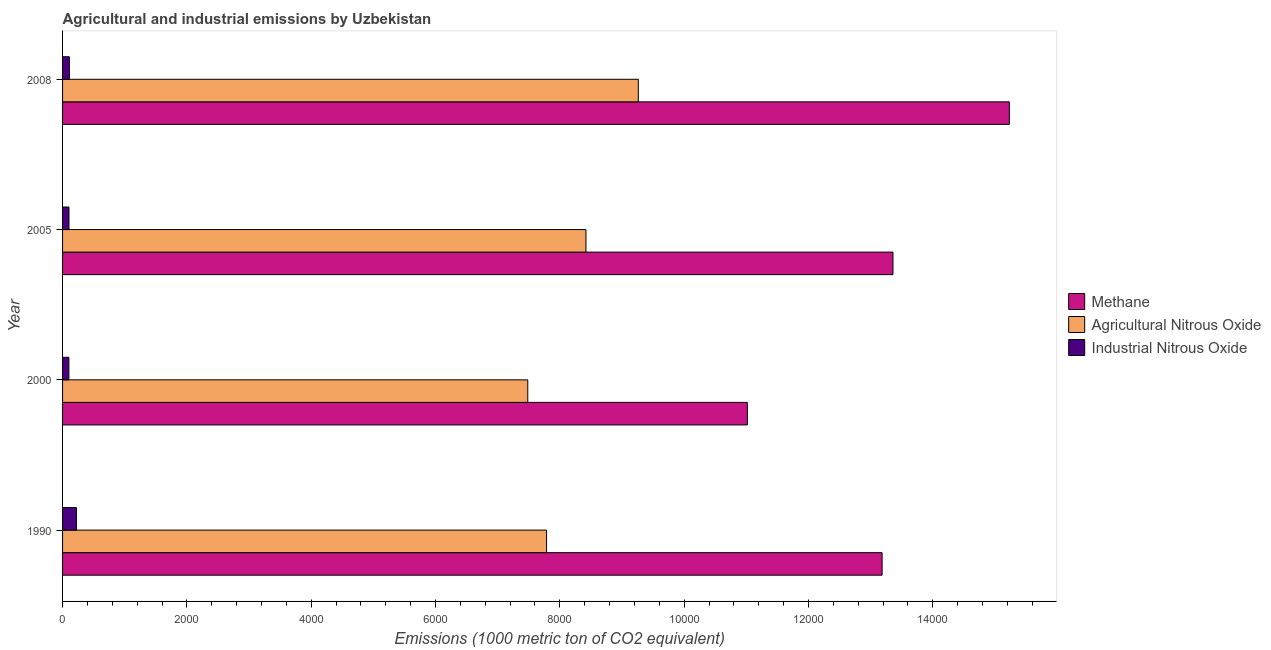How many different coloured bars are there?
Ensure brevity in your answer.  3. How many groups of bars are there?
Your answer should be very brief. 4. Are the number of bars per tick equal to the number of legend labels?
Your answer should be very brief. Yes. How many bars are there on the 2nd tick from the bottom?
Make the answer very short. 3. What is the amount of methane emissions in 1990?
Ensure brevity in your answer.  1.32e+04. Across all years, what is the maximum amount of methane emissions?
Provide a short and direct response. 1.52e+04. Across all years, what is the minimum amount of industrial nitrous oxide emissions?
Make the answer very short. 101.6. In which year was the amount of agricultural nitrous oxide emissions maximum?
Your response must be concise. 2008. In which year was the amount of industrial nitrous oxide emissions minimum?
Keep it short and to the point. 2000. What is the total amount of agricultural nitrous oxide emissions in the graph?
Offer a very short reply. 3.30e+04. What is the difference between the amount of industrial nitrous oxide emissions in 2005 and that in 2008?
Provide a short and direct response. -6.2. What is the difference between the amount of industrial nitrous oxide emissions in 2000 and the amount of methane emissions in 2005?
Offer a very short reply. -1.33e+04. What is the average amount of methane emissions per year?
Offer a very short reply. 1.32e+04. In the year 2008, what is the difference between the amount of methane emissions and amount of industrial nitrous oxide emissions?
Offer a terse response. 1.51e+04. In how many years, is the amount of industrial nitrous oxide emissions greater than 15200 metric ton?
Give a very brief answer. 0. What is the ratio of the amount of methane emissions in 2005 to that in 2008?
Offer a very short reply. 0.88. What is the difference between the highest and the second highest amount of industrial nitrous oxide emissions?
Give a very brief answer. 113.8. What is the difference between the highest and the lowest amount of methane emissions?
Provide a short and direct response. 4214.5. Is the sum of the amount of methane emissions in 1990 and 2005 greater than the maximum amount of agricultural nitrous oxide emissions across all years?
Your answer should be compact. Yes. What does the 3rd bar from the top in 2000 represents?
Ensure brevity in your answer.  Methane. What does the 2nd bar from the bottom in 2008 represents?
Ensure brevity in your answer.  Agricultural Nitrous Oxide. Are all the bars in the graph horizontal?
Give a very brief answer. Yes. What is the difference between two consecutive major ticks on the X-axis?
Ensure brevity in your answer.  2000. Are the values on the major ticks of X-axis written in scientific E-notation?
Make the answer very short. No. Does the graph contain grids?
Your answer should be compact. No. Where does the legend appear in the graph?
Offer a very short reply. Center right. How many legend labels are there?
Keep it short and to the point. 3. What is the title of the graph?
Ensure brevity in your answer.  Agricultural and industrial emissions by Uzbekistan. Does "Spain" appear as one of the legend labels in the graph?
Make the answer very short. No. What is the label or title of the X-axis?
Provide a short and direct response. Emissions (1000 metric ton of CO2 equivalent). What is the Emissions (1000 metric ton of CO2 equivalent) of Methane in 1990?
Give a very brief answer. 1.32e+04. What is the Emissions (1000 metric ton of CO2 equivalent) of Agricultural Nitrous Oxide in 1990?
Ensure brevity in your answer.  7786.3. What is the Emissions (1000 metric ton of CO2 equivalent) in Industrial Nitrous Oxide in 1990?
Provide a succinct answer. 223.2. What is the Emissions (1000 metric ton of CO2 equivalent) of Methane in 2000?
Offer a terse response. 1.10e+04. What is the Emissions (1000 metric ton of CO2 equivalent) in Agricultural Nitrous Oxide in 2000?
Give a very brief answer. 7484.2. What is the Emissions (1000 metric ton of CO2 equivalent) of Industrial Nitrous Oxide in 2000?
Your answer should be compact. 101.6. What is the Emissions (1000 metric ton of CO2 equivalent) of Methane in 2005?
Ensure brevity in your answer.  1.34e+04. What is the Emissions (1000 metric ton of CO2 equivalent) in Agricultural Nitrous Oxide in 2005?
Your answer should be compact. 8420.1. What is the Emissions (1000 metric ton of CO2 equivalent) in Industrial Nitrous Oxide in 2005?
Your answer should be compact. 103.2. What is the Emissions (1000 metric ton of CO2 equivalent) in Methane in 2008?
Your response must be concise. 1.52e+04. What is the Emissions (1000 metric ton of CO2 equivalent) in Agricultural Nitrous Oxide in 2008?
Make the answer very short. 9262.5. What is the Emissions (1000 metric ton of CO2 equivalent) of Industrial Nitrous Oxide in 2008?
Offer a terse response. 109.4. Across all years, what is the maximum Emissions (1000 metric ton of CO2 equivalent) of Methane?
Make the answer very short. 1.52e+04. Across all years, what is the maximum Emissions (1000 metric ton of CO2 equivalent) in Agricultural Nitrous Oxide?
Offer a terse response. 9262.5. Across all years, what is the maximum Emissions (1000 metric ton of CO2 equivalent) of Industrial Nitrous Oxide?
Make the answer very short. 223.2. Across all years, what is the minimum Emissions (1000 metric ton of CO2 equivalent) of Methane?
Keep it short and to the point. 1.10e+04. Across all years, what is the minimum Emissions (1000 metric ton of CO2 equivalent) of Agricultural Nitrous Oxide?
Offer a terse response. 7484.2. Across all years, what is the minimum Emissions (1000 metric ton of CO2 equivalent) in Industrial Nitrous Oxide?
Your answer should be very brief. 101.6. What is the total Emissions (1000 metric ton of CO2 equivalent) of Methane in the graph?
Provide a succinct answer. 5.28e+04. What is the total Emissions (1000 metric ton of CO2 equivalent) in Agricultural Nitrous Oxide in the graph?
Your answer should be compact. 3.30e+04. What is the total Emissions (1000 metric ton of CO2 equivalent) in Industrial Nitrous Oxide in the graph?
Provide a short and direct response. 537.4. What is the difference between the Emissions (1000 metric ton of CO2 equivalent) of Methane in 1990 and that in 2000?
Your answer should be very brief. 2168. What is the difference between the Emissions (1000 metric ton of CO2 equivalent) in Agricultural Nitrous Oxide in 1990 and that in 2000?
Your answer should be compact. 302.1. What is the difference between the Emissions (1000 metric ton of CO2 equivalent) in Industrial Nitrous Oxide in 1990 and that in 2000?
Offer a very short reply. 121.6. What is the difference between the Emissions (1000 metric ton of CO2 equivalent) of Methane in 1990 and that in 2005?
Offer a very short reply. -174.6. What is the difference between the Emissions (1000 metric ton of CO2 equivalent) in Agricultural Nitrous Oxide in 1990 and that in 2005?
Provide a succinct answer. -633.8. What is the difference between the Emissions (1000 metric ton of CO2 equivalent) of Industrial Nitrous Oxide in 1990 and that in 2005?
Make the answer very short. 120. What is the difference between the Emissions (1000 metric ton of CO2 equivalent) in Methane in 1990 and that in 2008?
Provide a succinct answer. -2046.5. What is the difference between the Emissions (1000 metric ton of CO2 equivalent) in Agricultural Nitrous Oxide in 1990 and that in 2008?
Provide a short and direct response. -1476.2. What is the difference between the Emissions (1000 metric ton of CO2 equivalent) in Industrial Nitrous Oxide in 1990 and that in 2008?
Your answer should be very brief. 113.8. What is the difference between the Emissions (1000 metric ton of CO2 equivalent) of Methane in 2000 and that in 2005?
Provide a short and direct response. -2342.6. What is the difference between the Emissions (1000 metric ton of CO2 equivalent) of Agricultural Nitrous Oxide in 2000 and that in 2005?
Your response must be concise. -935.9. What is the difference between the Emissions (1000 metric ton of CO2 equivalent) of Industrial Nitrous Oxide in 2000 and that in 2005?
Keep it short and to the point. -1.6. What is the difference between the Emissions (1000 metric ton of CO2 equivalent) in Methane in 2000 and that in 2008?
Ensure brevity in your answer.  -4214.5. What is the difference between the Emissions (1000 metric ton of CO2 equivalent) in Agricultural Nitrous Oxide in 2000 and that in 2008?
Your answer should be very brief. -1778.3. What is the difference between the Emissions (1000 metric ton of CO2 equivalent) of Methane in 2005 and that in 2008?
Provide a succinct answer. -1871.9. What is the difference between the Emissions (1000 metric ton of CO2 equivalent) of Agricultural Nitrous Oxide in 2005 and that in 2008?
Your answer should be very brief. -842.4. What is the difference between the Emissions (1000 metric ton of CO2 equivalent) in Industrial Nitrous Oxide in 2005 and that in 2008?
Provide a succinct answer. -6.2. What is the difference between the Emissions (1000 metric ton of CO2 equivalent) of Methane in 1990 and the Emissions (1000 metric ton of CO2 equivalent) of Agricultural Nitrous Oxide in 2000?
Provide a succinct answer. 5700.2. What is the difference between the Emissions (1000 metric ton of CO2 equivalent) in Methane in 1990 and the Emissions (1000 metric ton of CO2 equivalent) in Industrial Nitrous Oxide in 2000?
Make the answer very short. 1.31e+04. What is the difference between the Emissions (1000 metric ton of CO2 equivalent) of Agricultural Nitrous Oxide in 1990 and the Emissions (1000 metric ton of CO2 equivalent) of Industrial Nitrous Oxide in 2000?
Ensure brevity in your answer.  7684.7. What is the difference between the Emissions (1000 metric ton of CO2 equivalent) in Methane in 1990 and the Emissions (1000 metric ton of CO2 equivalent) in Agricultural Nitrous Oxide in 2005?
Make the answer very short. 4764.3. What is the difference between the Emissions (1000 metric ton of CO2 equivalent) in Methane in 1990 and the Emissions (1000 metric ton of CO2 equivalent) in Industrial Nitrous Oxide in 2005?
Keep it short and to the point. 1.31e+04. What is the difference between the Emissions (1000 metric ton of CO2 equivalent) in Agricultural Nitrous Oxide in 1990 and the Emissions (1000 metric ton of CO2 equivalent) in Industrial Nitrous Oxide in 2005?
Offer a terse response. 7683.1. What is the difference between the Emissions (1000 metric ton of CO2 equivalent) of Methane in 1990 and the Emissions (1000 metric ton of CO2 equivalent) of Agricultural Nitrous Oxide in 2008?
Make the answer very short. 3921.9. What is the difference between the Emissions (1000 metric ton of CO2 equivalent) in Methane in 1990 and the Emissions (1000 metric ton of CO2 equivalent) in Industrial Nitrous Oxide in 2008?
Offer a terse response. 1.31e+04. What is the difference between the Emissions (1000 metric ton of CO2 equivalent) of Agricultural Nitrous Oxide in 1990 and the Emissions (1000 metric ton of CO2 equivalent) of Industrial Nitrous Oxide in 2008?
Offer a terse response. 7676.9. What is the difference between the Emissions (1000 metric ton of CO2 equivalent) in Methane in 2000 and the Emissions (1000 metric ton of CO2 equivalent) in Agricultural Nitrous Oxide in 2005?
Give a very brief answer. 2596.3. What is the difference between the Emissions (1000 metric ton of CO2 equivalent) in Methane in 2000 and the Emissions (1000 metric ton of CO2 equivalent) in Industrial Nitrous Oxide in 2005?
Give a very brief answer. 1.09e+04. What is the difference between the Emissions (1000 metric ton of CO2 equivalent) of Agricultural Nitrous Oxide in 2000 and the Emissions (1000 metric ton of CO2 equivalent) of Industrial Nitrous Oxide in 2005?
Your answer should be compact. 7381. What is the difference between the Emissions (1000 metric ton of CO2 equivalent) in Methane in 2000 and the Emissions (1000 metric ton of CO2 equivalent) in Agricultural Nitrous Oxide in 2008?
Ensure brevity in your answer.  1753.9. What is the difference between the Emissions (1000 metric ton of CO2 equivalent) in Methane in 2000 and the Emissions (1000 metric ton of CO2 equivalent) in Industrial Nitrous Oxide in 2008?
Offer a very short reply. 1.09e+04. What is the difference between the Emissions (1000 metric ton of CO2 equivalent) in Agricultural Nitrous Oxide in 2000 and the Emissions (1000 metric ton of CO2 equivalent) in Industrial Nitrous Oxide in 2008?
Provide a short and direct response. 7374.8. What is the difference between the Emissions (1000 metric ton of CO2 equivalent) of Methane in 2005 and the Emissions (1000 metric ton of CO2 equivalent) of Agricultural Nitrous Oxide in 2008?
Your answer should be compact. 4096.5. What is the difference between the Emissions (1000 metric ton of CO2 equivalent) of Methane in 2005 and the Emissions (1000 metric ton of CO2 equivalent) of Industrial Nitrous Oxide in 2008?
Make the answer very short. 1.32e+04. What is the difference between the Emissions (1000 metric ton of CO2 equivalent) in Agricultural Nitrous Oxide in 2005 and the Emissions (1000 metric ton of CO2 equivalent) in Industrial Nitrous Oxide in 2008?
Your answer should be compact. 8310.7. What is the average Emissions (1000 metric ton of CO2 equivalent) in Methane per year?
Your answer should be compact. 1.32e+04. What is the average Emissions (1000 metric ton of CO2 equivalent) in Agricultural Nitrous Oxide per year?
Your answer should be compact. 8238.27. What is the average Emissions (1000 metric ton of CO2 equivalent) in Industrial Nitrous Oxide per year?
Keep it short and to the point. 134.35. In the year 1990, what is the difference between the Emissions (1000 metric ton of CO2 equivalent) in Methane and Emissions (1000 metric ton of CO2 equivalent) in Agricultural Nitrous Oxide?
Provide a succinct answer. 5398.1. In the year 1990, what is the difference between the Emissions (1000 metric ton of CO2 equivalent) of Methane and Emissions (1000 metric ton of CO2 equivalent) of Industrial Nitrous Oxide?
Provide a short and direct response. 1.30e+04. In the year 1990, what is the difference between the Emissions (1000 metric ton of CO2 equivalent) of Agricultural Nitrous Oxide and Emissions (1000 metric ton of CO2 equivalent) of Industrial Nitrous Oxide?
Offer a very short reply. 7563.1. In the year 2000, what is the difference between the Emissions (1000 metric ton of CO2 equivalent) of Methane and Emissions (1000 metric ton of CO2 equivalent) of Agricultural Nitrous Oxide?
Keep it short and to the point. 3532.2. In the year 2000, what is the difference between the Emissions (1000 metric ton of CO2 equivalent) of Methane and Emissions (1000 metric ton of CO2 equivalent) of Industrial Nitrous Oxide?
Keep it short and to the point. 1.09e+04. In the year 2000, what is the difference between the Emissions (1000 metric ton of CO2 equivalent) in Agricultural Nitrous Oxide and Emissions (1000 metric ton of CO2 equivalent) in Industrial Nitrous Oxide?
Give a very brief answer. 7382.6. In the year 2005, what is the difference between the Emissions (1000 metric ton of CO2 equivalent) in Methane and Emissions (1000 metric ton of CO2 equivalent) in Agricultural Nitrous Oxide?
Offer a very short reply. 4938.9. In the year 2005, what is the difference between the Emissions (1000 metric ton of CO2 equivalent) in Methane and Emissions (1000 metric ton of CO2 equivalent) in Industrial Nitrous Oxide?
Provide a short and direct response. 1.33e+04. In the year 2005, what is the difference between the Emissions (1000 metric ton of CO2 equivalent) of Agricultural Nitrous Oxide and Emissions (1000 metric ton of CO2 equivalent) of Industrial Nitrous Oxide?
Keep it short and to the point. 8316.9. In the year 2008, what is the difference between the Emissions (1000 metric ton of CO2 equivalent) of Methane and Emissions (1000 metric ton of CO2 equivalent) of Agricultural Nitrous Oxide?
Offer a terse response. 5968.4. In the year 2008, what is the difference between the Emissions (1000 metric ton of CO2 equivalent) in Methane and Emissions (1000 metric ton of CO2 equivalent) in Industrial Nitrous Oxide?
Your answer should be very brief. 1.51e+04. In the year 2008, what is the difference between the Emissions (1000 metric ton of CO2 equivalent) in Agricultural Nitrous Oxide and Emissions (1000 metric ton of CO2 equivalent) in Industrial Nitrous Oxide?
Provide a short and direct response. 9153.1. What is the ratio of the Emissions (1000 metric ton of CO2 equivalent) in Methane in 1990 to that in 2000?
Provide a succinct answer. 1.2. What is the ratio of the Emissions (1000 metric ton of CO2 equivalent) in Agricultural Nitrous Oxide in 1990 to that in 2000?
Make the answer very short. 1.04. What is the ratio of the Emissions (1000 metric ton of CO2 equivalent) of Industrial Nitrous Oxide in 1990 to that in 2000?
Your answer should be compact. 2.2. What is the ratio of the Emissions (1000 metric ton of CO2 equivalent) of Methane in 1990 to that in 2005?
Your answer should be very brief. 0.99. What is the ratio of the Emissions (1000 metric ton of CO2 equivalent) of Agricultural Nitrous Oxide in 1990 to that in 2005?
Keep it short and to the point. 0.92. What is the ratio of the Emissions (1000 metric ton of CO2 equivalent) of Industrial Nitrous Oxide in 1990 to that in 2005?
Your answer should be very brief. 2.16. What is the ratio of the Emissions (1000 metric ton of CO2 equivalent) in Methane in 1990 to that in 2008?
Your answer should be compact. 0.87. What is the ratio of the Emissions (1000 metric ton of CO2 equivalent) of Agricultural Nitrous Oxide in 1990 to that in 2008?
Keep it short and to the point. 0.84. What is the ratio of the Emissions (1000 metric ton of CO2 equivalent) in Industrial Nitrous Oxide in 1990 to that in 2008?
Offer a very short reply. 2.04. What is the ratio of the Emissions (1000 metric ton of CO2 equivalent) in Methane in 2000 to that in 2005?
Provide a short and direct response. 0.82. What is the ratio of the Emissions (1000 metric ton of CO2 equivalent) in Agricultural Nitrous Oxide in 2000 to that in 2005?
Your response must be concise. 0.89. What is the ratio of the Emissions (1000 metric ton of CO2 equivalent) in Industrial Nitrous Oxide in 2000 to that in 2005?
Provide a short and direct response. 0.98. What is the ratio of the Emissions (1000 metric ton of CO2 equivalent) of Methane in 2000 to that in 2008?
Offer a very short reply. 0.72. What is the ratio of the Emissions (1000 metric ton of CO2 equivalent) of Agricultural Nitrous Oxide in 2000 to that in 2008?
Ensure brevity in your answer.  0.81. What is the ratio of the Emissions (1000 metric ton of CO2 equivalent) of Industrial Nitrous Oxide in 2000 to that in 2008?
Offer a very short reply. 0.93. What is the ratio of the Emissions (1000 metric ton of CO2 equivalent) of Methane in 2005 to that in 2008?
Your answer should be very brief. 0.88. What is the ratio of the Emissions (1000 metric ton of CO2 equivalent) in Industrial Nitrous Oxide in 2005 to that in 2008?
Make the answer very short. 0.94. What is the difference between the highest and the second highest Emissions (1000 metric ton of CO2 equivalent) of Methane?
Keep it short and to the point. 1871.9. What is the difference between the highest and the second highest Emissions (1000 metric ton of CO2 equivalent) of Agricultural Nitrous Oxide?
Give a very brief answer. 842.4. What is the difference between the highest and the second highest Emissions (1000 metric ton of CO2 equivalent) in Industrial Nitrous Oxide?
Ensure brevity in your answer.  113.8. What is the difference between the highest and the lowest Emissions (1000 metric ton of CO2 equivalent) of Methane?
Ensure brevity in your answer.  4214.5. What is the difference between the highest and the lowest Emissions (1000 metric ton of CO2 equivalent) of Agricultural Nitrous Oxide?
Ensure brevity in your answer.  1778.3. What is the difference between the highest and the lowest Emissions (1000 metric ton of CO2 equivalent) of Industrial Nitrous Oxide?
Offer a terse response. 121.6. 